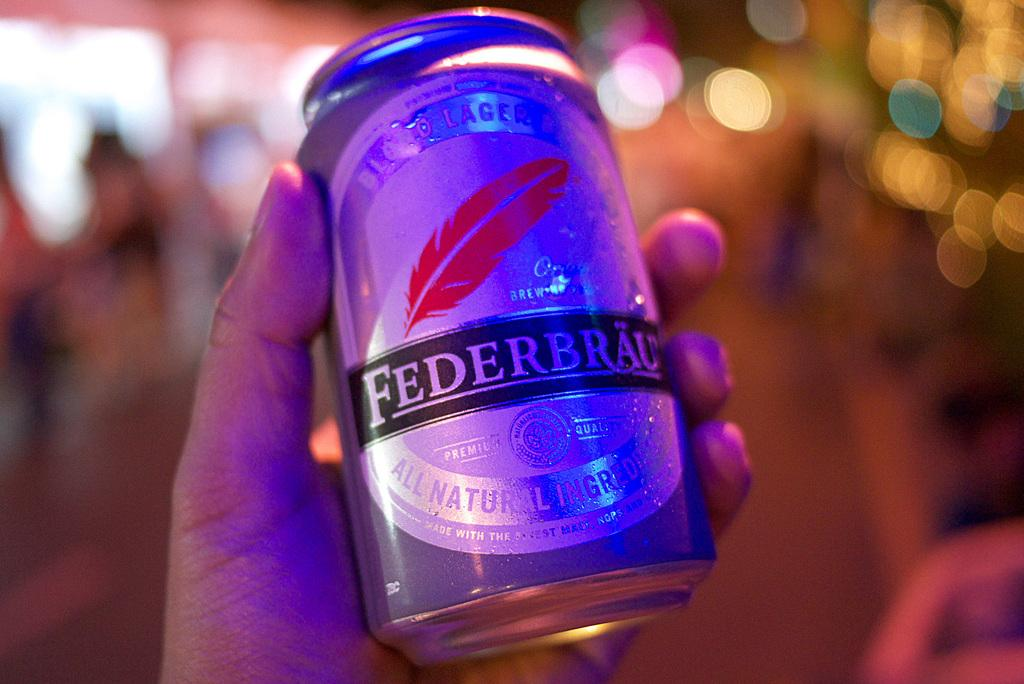<image>
Provide a brief description of the given image. Man holding a can of beer by the maker Federbrau. 